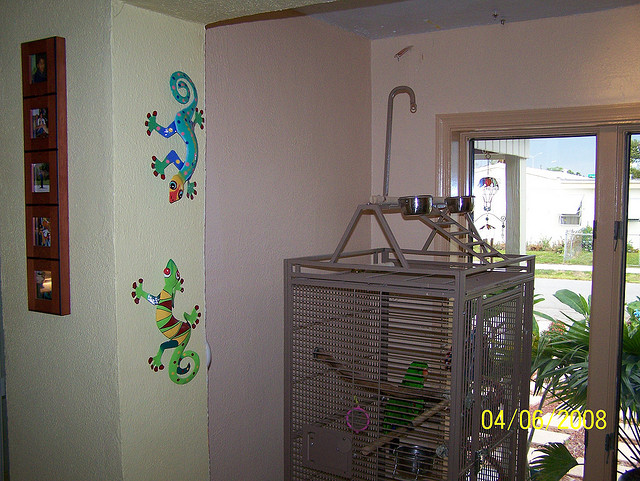Extract all visible text content from this image. 04 06 2008 